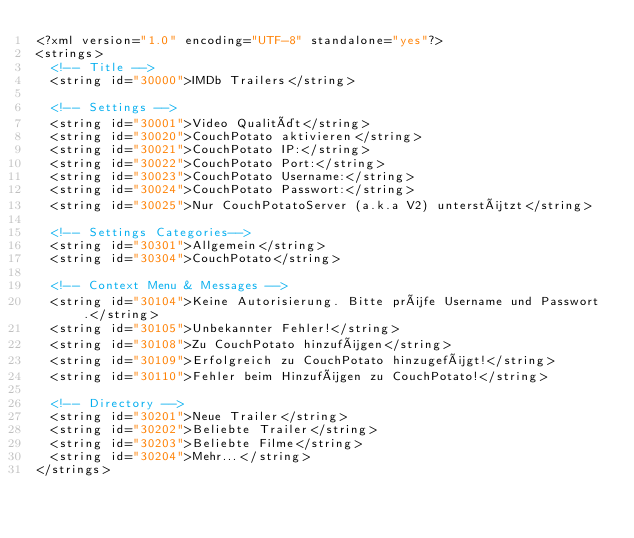<code> <loc_0><loc_0><loc_500><loc_500><_XML_><?xml version="1.0" encoding="UTF-8" standalone="yes"?>
<strings>
  <!-- Title -->
  <string id="30000">IMDb Trailers</string>

  <!-- Settings -->
  <string id="30001">Video Qualität</string>
  <string id="30020">CouchPotato aktivieren</string>
  <string id="30021">CouchPotato IP:</string>
  <string id="30022">CouchPotato Port:</string>
  <string id="30023">CouchPotato Username:</string>
  <string id="30024">CouchPotato Passwort:</string>
  <string id="30025">Nur CouchPotatoServer (a.k.a V2) unterstützt</string>
  
  <!-- Settings Categories-->
  <string id="30301">Allgemein</string>
  <string id="30304">CouchPotato</string> 
  
  <!-- Context Menu & Messages -->
  <string id="30104">Keine Autorisierung. Bitte prüfe Username und Passwort.</string>
  <string id="30105">Unbekannter Fehler!</string>
  <string id="30108">Zu CouchPotato hinzufügen</string>
  <string id="30109">Erfolgreich zu CouchPotato hinzugefügt!</string>
  <string id="30110">Fehler beim Hinzufügen zu CouchPotato!</string>
  
  <!-- Directory -->
  <string id="30201">Neue Trailer</string>
  <string id="30202">Beliebte Trailer</string>
  <string id="30203">Beliebte Filme</string>
  <string id="30204">Mehr...</string>
</strings></code> 